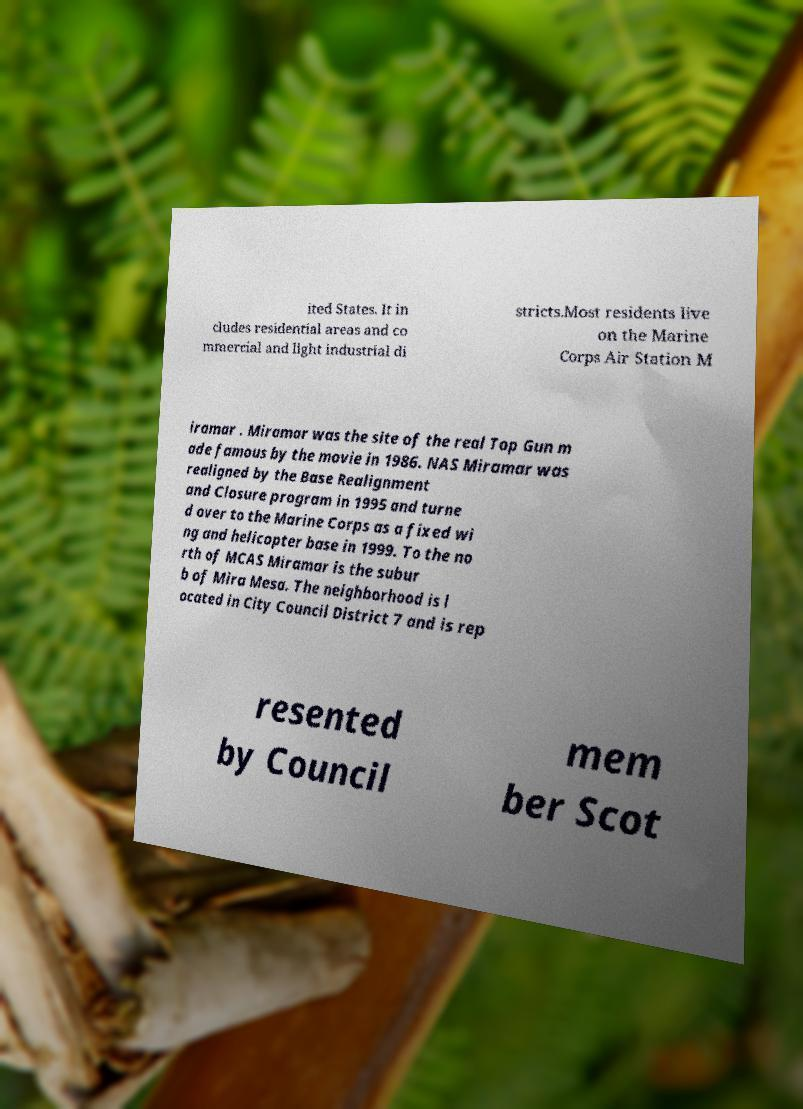Can you read and provide the text displayed in the image?This photo seems to have some interesting text. Can you extract and type it out for me? ited States. It in cludes residential areas and co mmercial and light industrial di stricts.Most residents live on the Marine Corps Air Station M iramar . Miramar was the site of the real Top Gun m ade famous by the movie in 1986. NAS Miramar was realigned by the Base Realignment and Closure program in 1995 and turne d over to the Marine Corps as a fixed wi ng and helicopter base in 1999. To the no rth of MCAS Miramar is the subur b of Mira Mesa. The neighborhood is l ocated in City Council District 7 and is rep resented by Council mem ber Scot 